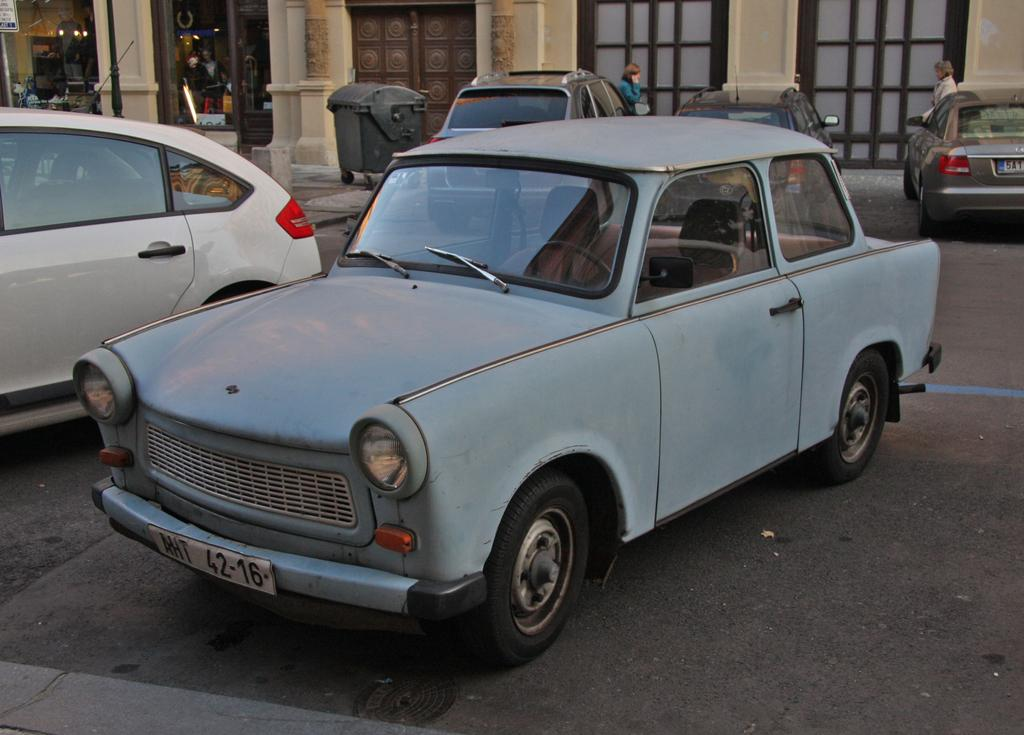What can be seen on the road in the image? There are cars on the road in the image. What object is present near the cars? There is a trash bin in the image. How many people are standing near the cars in the image? Two persons are standing near the cars in the image. What is visible in the background of the image? There is a building in the background of the image. What word is written on the clock in the image? There is no clock present in the image, so it is not possible to answer that question. 